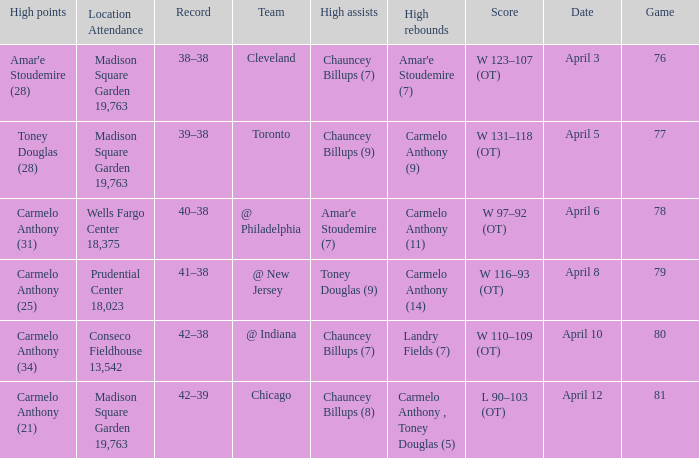Name the date for cleveland April 3. 